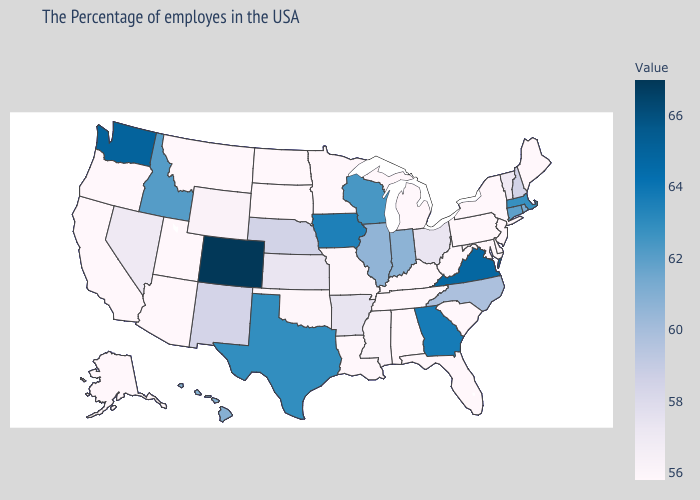Among the states that border Washington , which have the lowest value?
Keep it brief. Oregon. Does Florida have the highest value in the USA?
Answer briefly. No. Does the map have missing data?
Write a very short answer. No. Which states have the lowest value in the USA?
Keep it brief. Maine, New York, New Jersey, Delaware, Maryland, Pennsylvania, South Carolina, West Virginia, Florida, Michigan, Kentucky, Alabama, Tennessee, Louisiana, Minnesota, South Dakota, North Dakota, Utah, Montana, Arizona, California, Oregon, Alaska. Is the legend a continuous bar?
Be succinct. Yes. 